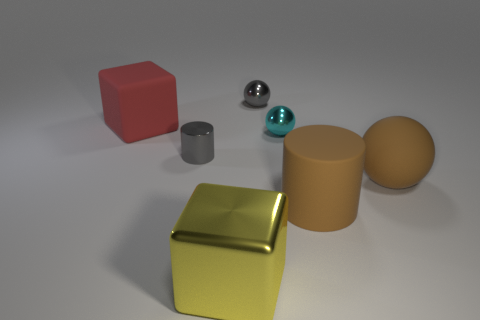How many other objects are there of the same material as the big ball?
Provide a succinct answer. 2. There is a cyan thing that is the same size as the shiny cylinder; what is it made of?
Provide a succinct answer. Metal. What number of cyan things are large shiny objects or cylinders?
Your response must be concise. 0. There is a big thing that is to the left of the gray metallic sphere and behind the big yellow block; what is its color?
Give a very brief answer. Red. Do the large cube in front of the small cyan object and the tiny ball that is behind the cyan metal thing have the same material?
Your answer should be compact. Yes. Are there more large brown rubber things in front of the gray ball than large red things in front of the red thing?
Your answer should be compact. Yes. There is a cyan object that is the same size as the gray metallic cylinder; what shape is it?
Offer a very short reply. Sphere. How many objects are either big shiny blocks or small metallic things on the right side of the small gray shiny cylinder?
Your answer should be compact. 3. Is the big ball the same color as the big rubber cylinder?
Provide a short and direct response. Yes. There is a large yellow metal object; what number of rubber objects are left of it?
Make the answer very short. 1. 